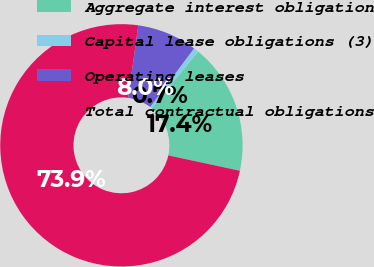Convert chart. <chart><loc_0><loc_0><loc_500><loc_500><pie_chart><fcel>Aggregate interest obligation<fcel>Capital lease obligations (3)<fcel>Operating leases<fcel>Total contractual obligations<nl><fcel>17.44%<fcel>0.69%<fcel>8.01%<fcel>73.87%<nl></chart> 